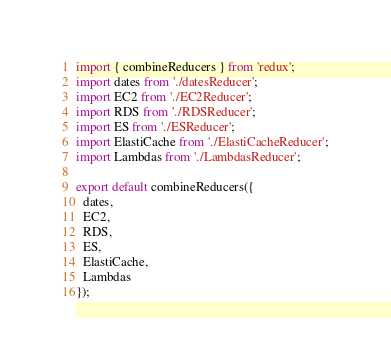<code> <loc_0><loc_0><loc_500><loc_500><_JavaScript_>import { combineReducers } from 'redux';
import dates from './datesReducer';
import EC2 from './EC2Reducer';
import RDS from './RDSReducer';
import ES from './ESReducer';
import ElastiCache from './ElastiCacheReducer';
import Lambdas from './LambdasReducer';

export default combineReducers({
  dates,
  EC2,
  RDS,
  ES,
  ElastiCache,
  Lambdas
});
</code> 